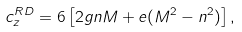Convert formula to latex. <formula><loc_0><loc_0><loc_500><loc_500>c ^ { R D } _ { z } = 6 \left [ 2 g n M + e ( M ^ { 2 } - n ^ { 2 } ) \right ] , \</formula> 